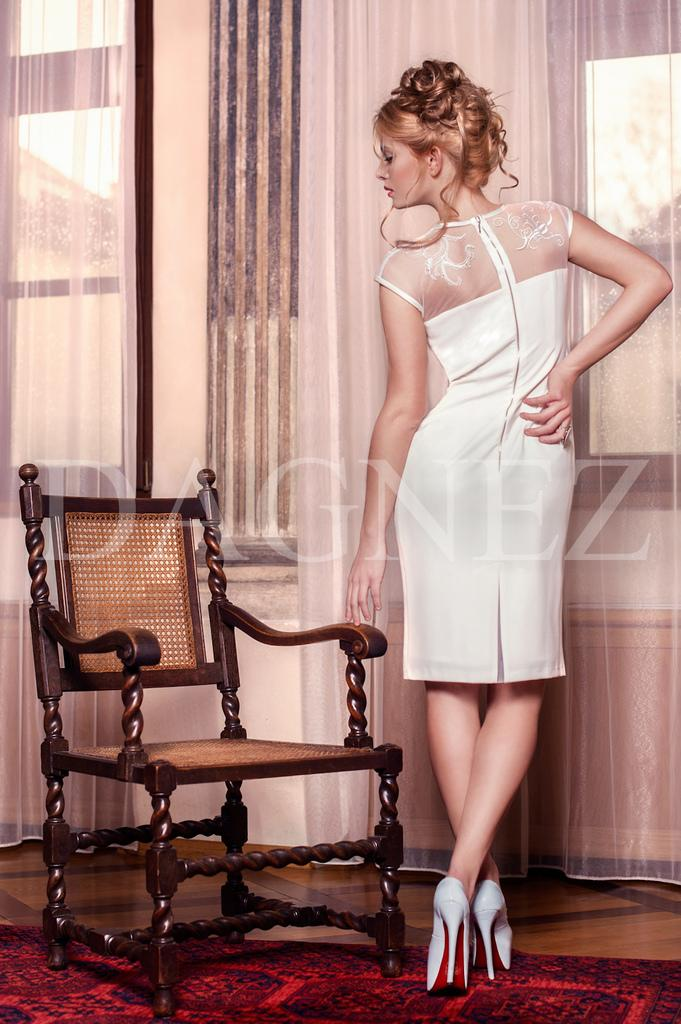Who is present in the image? There is a woman in the image. What is the woman wearing? The woman is wearing a white dress. What piece of furniture can be seen in the image? There is a chair in the image. How many rabbits are sitting on the woman's lap in the image? There are no rabbits present in the image. What is the relationship between the woman and the mother in the image? There is no mention of a mother in the image, as it only features a woman. 